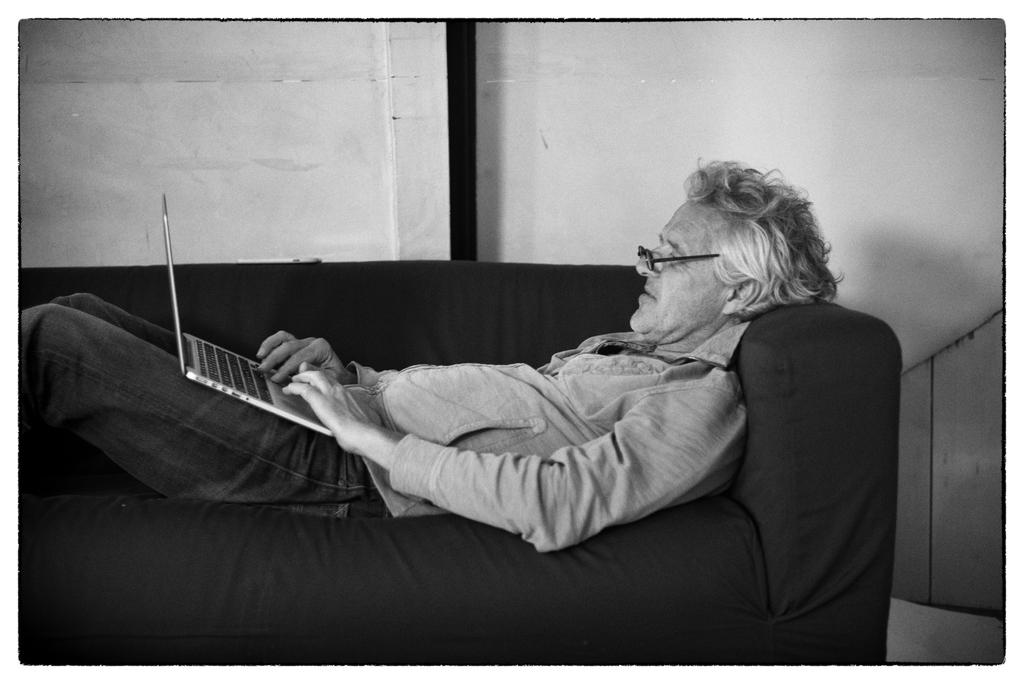Who is present in the image? There is a person in the image. What is the person doing in the image? The person is lying on a couch and handling a laptop. Where is the laptop placed on the person's body? The laptop is on the person's thighs. What accessory is the person wearing in the image? The person is wearing spectacles. How many women are visible in the harbor in the image? There is no harbor or women present in the image. What type of tank can be seen in the background of the image? There is no tank visible in the image. 